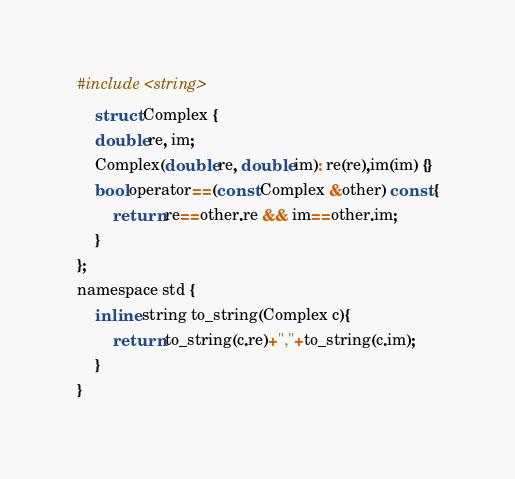<code> <loc_0><loc_0><loc_500><loc_500><_C_>#include <string>
    struct Complex {
    double re, im;
    Complex(double re, double im): re(re),im(im) {}
    bool operator==(const Complex &other) const {
        return re==other.re && im==other.im;
    }
};
namespace std {
    inline string to_string(Complex c){
        return to_string(c.re)+","+to_string(c.im);
    }
}</code> 